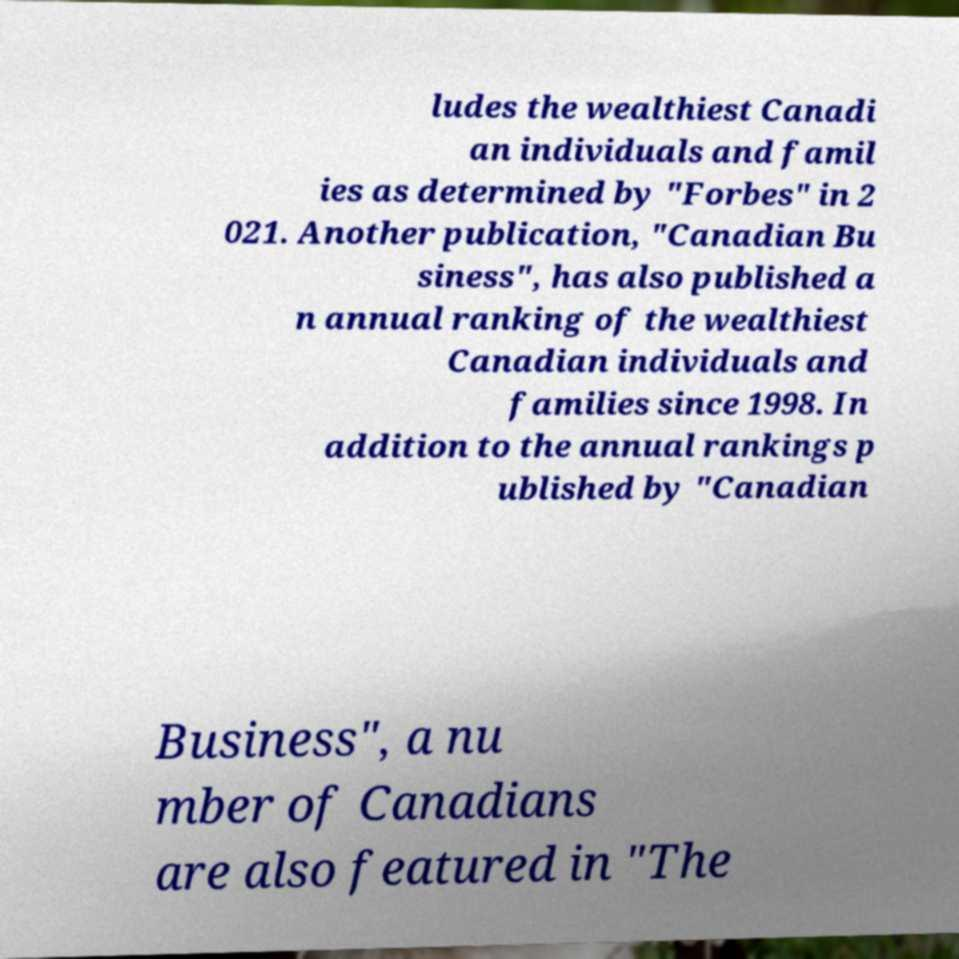Please identify and transcribe the text found in this image. ludes the wealthiest Canadi an individuals and famil ies as determined by "Forbes" in 2 021. Another publication, "Canadian Bu siness", has also published a n annual ranking of the wealthiest Canadian individuals and families since 1998. In addition to the annual rankings p ublished by "Canadian Business", a nu mber of Canadians are also featured in "The 